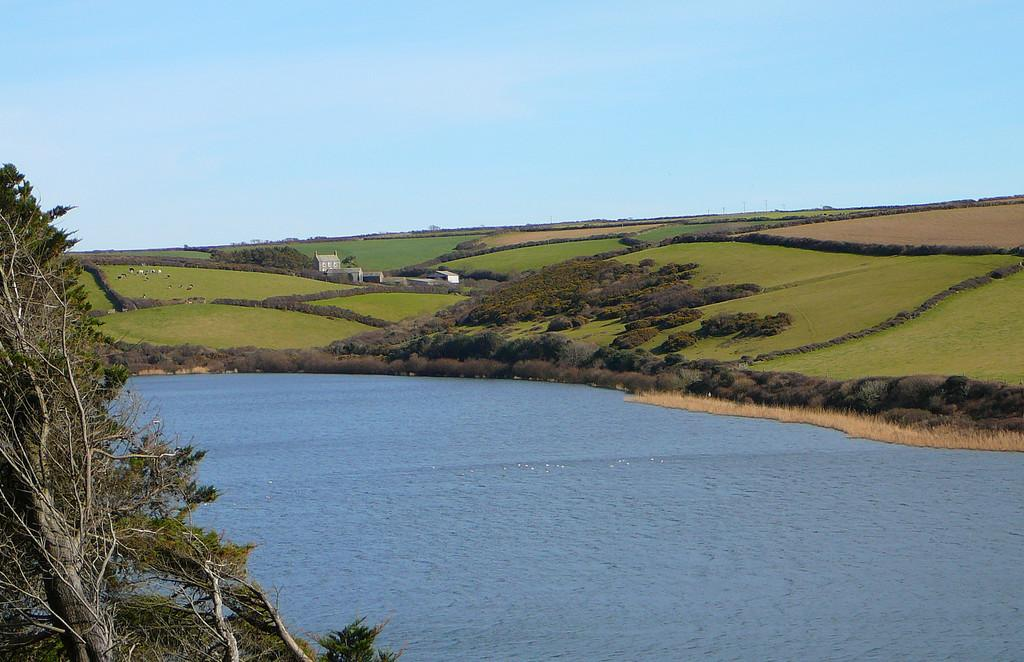What type of body of water is present in the image? There is a lake in the image. What type of vegetation can be seen in the image? There is grass, shrubs, and bushes visible in the image. Are there any man-made structures in the image? Yes, there are buildings in the image. What part of the natural environment is visible in the image? The ground and the sky are visible in the image. How many geese are visible in the wilderness in the image? There is no wilderness or geese present in the image. What type of test is being conducted in the image? There is no test being conducted in the image. 